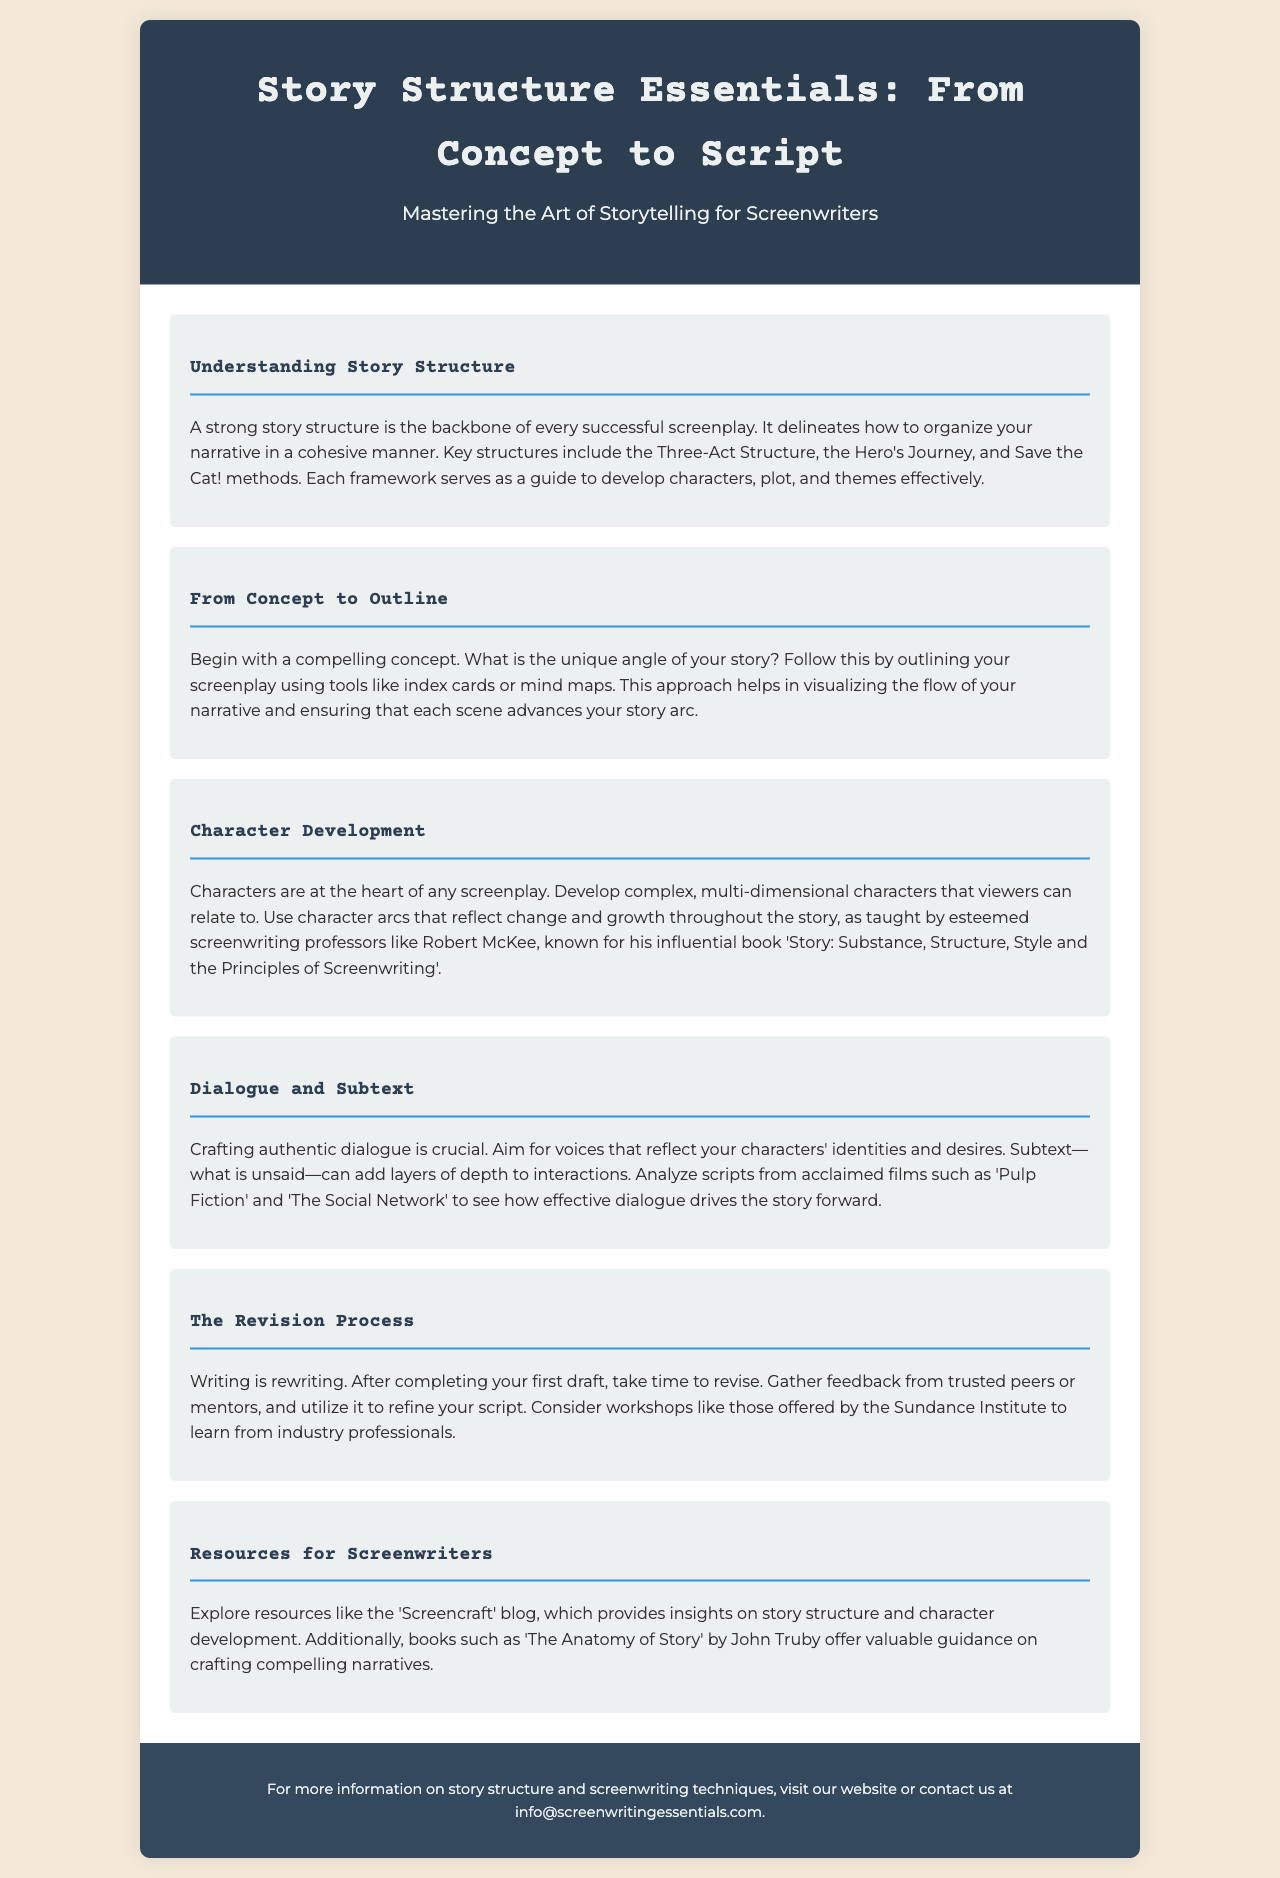What is the title of the brochure? The title of the brochure is prominently displayed in the header section, introducing the subject.
Answer: Story Structure Essentials: From Concept to Script Who is a notable figure mentioned in character development? The document references an esteemed screenwriting professor known for his influential book.
Answer: Robert McKee What method is one of the key structures for organizing narratives? The document lists several methods used to structure stories, highlighting them in the section on story structure.
Answer: Three-Act Structure What technique emphasizes what is unsaid in dialogue? The concept that adds depth to character interactions is defined in the dialogue and subtext section.
Answer: Subtext What is essential for effective character development? The document discusses the importance of certain qualities in characters that resonate with audiences in the character development section.
Answer: Complex, multi-dimensional characters What is the first step in the screenwriting process according to the brochure? The document outlines a sequence of steps, starting with the creation of a specific element of the screenplay.
Answer: Compelling concept What should writers consider after completing their first draft? The revision process is highlighted in the document, emphasizing the importance of gathering specific input.
Answer: Feedback Which blog is mentioned as a resource for screenwriters? The brochure recommends specific resources including a blog that provides insights on storytelling.
Answer: Screencraft Which acclaimed films are referenced to analyze dialogue? The document uses examples from well-known films to underscore the effectiveness of dialogue.
Answer: Pulp Fiction and The Social Network 